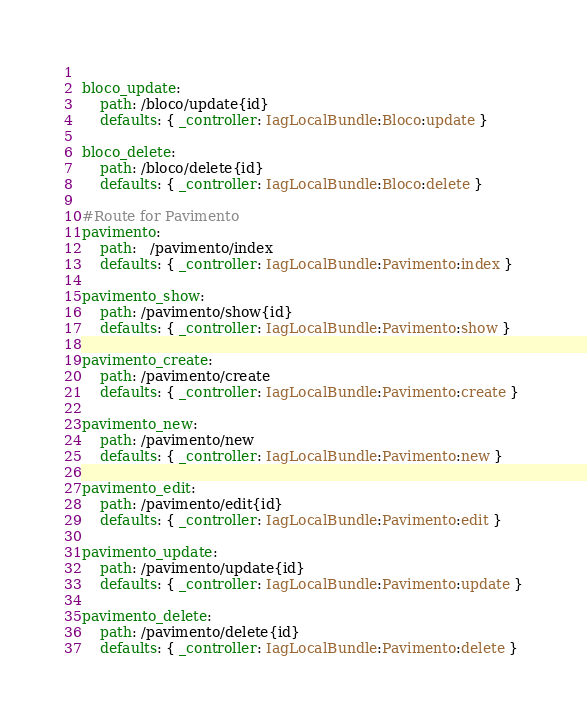<code> <loc_0><loc_0><loc_500><loc_500><_YAML_>    
bloco_update:
    path: /bloco/update{id}
    defaults: { _controller: IagLocalBundle:Bloco:update }
    
bloco_delete:
    path: /bloco/delete{id}
    defaults: { _controller: IagLocalBundle:Bloco:delete }
    
#Route for Pavimento
pavimento:
    path:   /pavimento/index
    defaults: { _controller: IagLocalBundle:Pavimento:index }
    
pavimento_show:
    path: /pavimento/show{id}
    defaults: { _controller: IagLocalBundle:Pavimento:show }

pavimento_create:
    path: /pavimento/create
    defaults: { _controller: IagLocalBundle:Pavimento:create }

pavimento_new:
    path: /pavimento/new
    defaults: { _controller: IagLocalBundle:Pavimento:new }
    
pavimento_edit:
    path: /pavimento/edit{id}
    defaults: { _controller: IagLocalBundle:Pavimento:edit }
    
pavimento_update:
    path: /pavimento/update{id}
    defaults: { _controller: IagLocalBundle:Pavimento:update }
    
pavimento_delete:
    path: /pavimento/delete{id}
    defaults: { _controller: IagLocalBundle:Pavimento:delete }</code> 